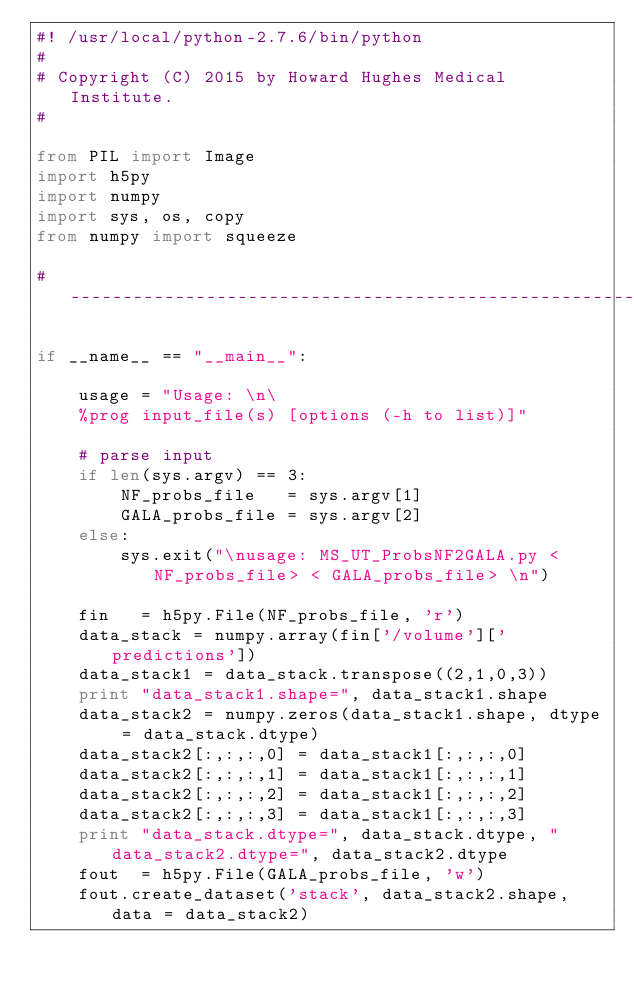Convert code to text. <code><loc_0><loc_0><loc_500><loc_500><_Python_>#! /usr/local/python-2.7.6/bin/python
#
# Copyright (C) 2015 by Howard Hughes Medical Institute.
#

from PIL import Image
import h5py
import numpy
import sys, os, copy
from numpy import squeeze

# ----------------------------------------------------------------------

if __name__ == "__main__":

    usage = "Usage: \n\
    %prog input_file(s) [options (-h to list)]"

    # parse input
    if len(sys.argv) == 3:      
        NF_probs_file   = sys.argv[1]
        GALA_probs_file = sys.argv[2]
    else:
        sys.exit("\nusage: MS_UT_ProbsNF2GALA.py <NF_probs_file> < GALA_probs_file> \n")

    fin   = h5py.File(NF_probs_file, 'r')
    data_stack = numpy.array(fin['/volume']['predictions'])
    data_stack1 = data_stack.transpose((2,1,0,3))
    print "data_stack1.shape=", data_stack1.shape
    data_stack2 = numpy.zeros(data_stack1.shape, dtype = data_stack.dtype)
    data_stack2[:,:,:,0] = data_stack1[:,:,:,0]
    data_stack2[:,:,:,1] = data_stack1[:,:,:,1]
    data_stack2[:,:,:,2] = data_stack1[:,:,:,2]
    data_stack2[:,:,:,3] = data_stack1[:,:,:,3]
    print "data_stack.dtype=", data_stack.dtype, " data_stack2.dtype=", data_stack2.dtype
    fout  = h5py.File(GALA_probs_file, 'w')
    fout.create_dataset('stack', data_stack2.shape, data = data_stack2)

      
</code> 